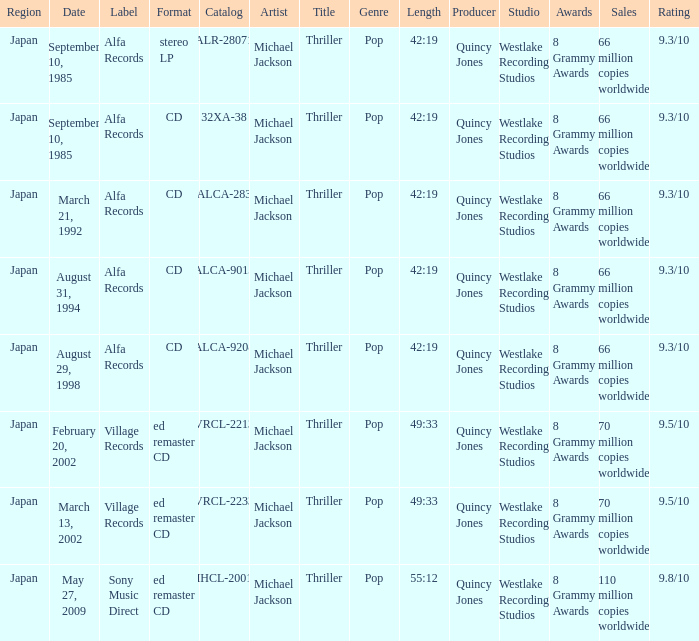Which catalog was arranged as a cd within the alfa records label? 32XA-38, ALCA-283, ALCA-9013, ALCA-9208. 